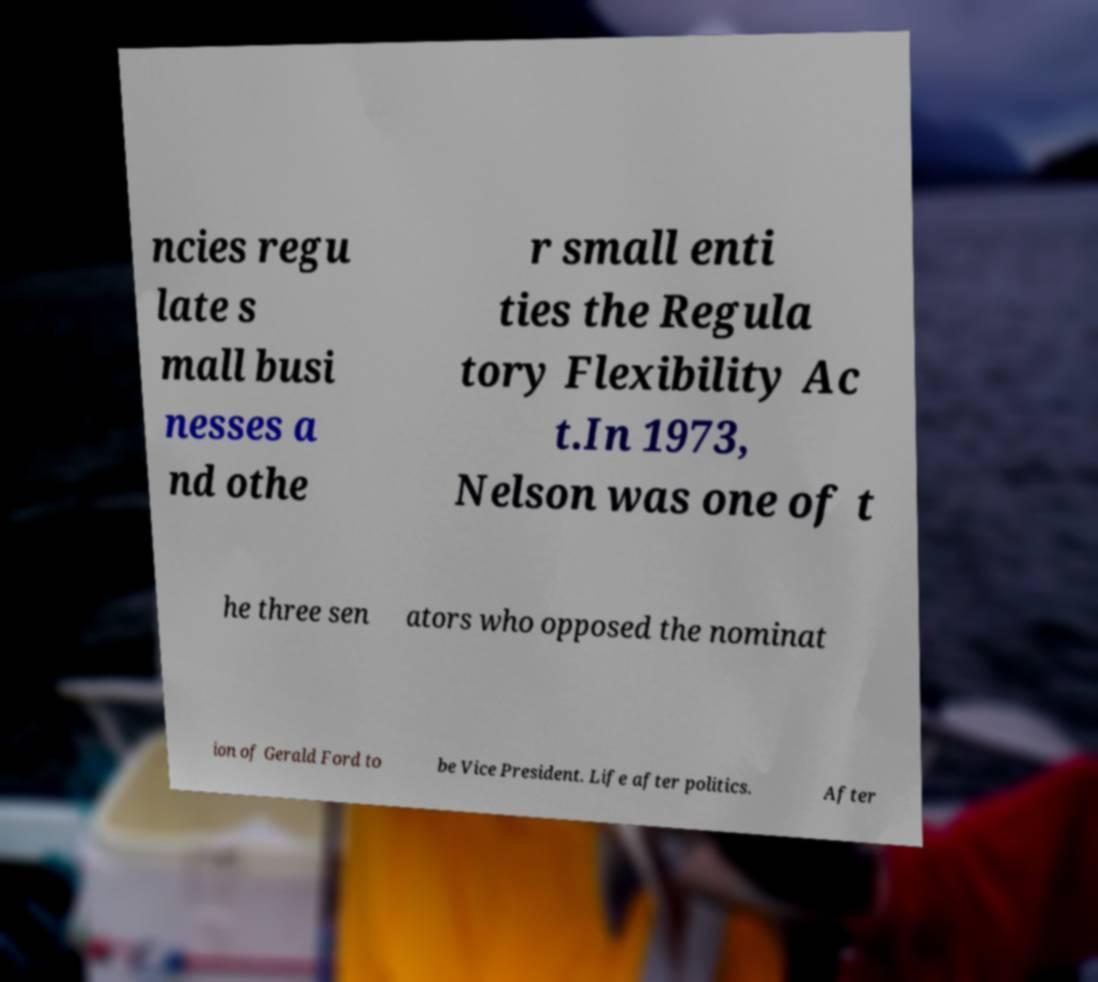What messages or text are displayed in this image? I need them in a readable, typed format. ncies regu late s mall busi nesses a nd othe r small enti ties the Regula tory Flexibility Ac t.In 1973, Nelson was one of t he three sen ators who opposed the nominat ion of Gerald Ford to be Vice President. Life after politics. After 